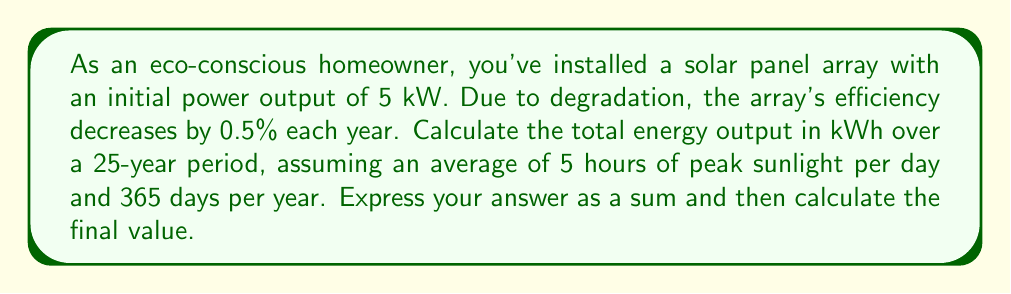Show me your answer to this math problem. Let's approach this step-by-step:

1) First, we need to calculate the energy output for each year, considering the degradation.

2) The initial power output is 5 kW. Each year, this decreases by 0.5%.

3) For any given year $n$ (where $n$ starts at 0), the power output will be:
   $$P_n = 5 \cdot (1 - 0.005)^n$$

4) To get the energy output for a year, we multiply this by the number of peak sunlight hours per day and the number of days in a year:
   $$E_n = P_n \cdot 5 \text{ hours} \cdot 365 \text{ days}$$

5) Substituting our power equation:
   $$E_n = 5 \cdot (1 - 0.005)^n \cdot 5 \cdot 365$$

6) Simplifying:
   $$E_n = 9125 \cdot (0.995)^n$$

7) Now, we need to sum this over 25 years (from n = 0 to 24):
   $$\text{Total Energy} = \sum_{n=0}^{24} 9125 \cdot (0.995)^n$$

8) This is a geometric series with first term $a = 9125$ and common ratio $r = 0.995$.
   We can use the formula for the sum of a geometric series:
   $$S_n = a\frac{1-r^n}{1-r}$$

9) Plugging in our values:
   $$\text{Total Energy} = 9125 \cdot \frac{1-(0.995)^{25}}{1-0.995}$$

10) Calculate:
    $$\text{Total Energy} = 9125 \cdot \frac{1-0.882311}{0.005} = 211,746.75 \text{ kWh}$$
Answer: The total energy output over 25 years is:
$$\sum_{n=0}^{24} 9125 \cdot (0.995)^n = 211,746.75 \text{ kWh}$$ 